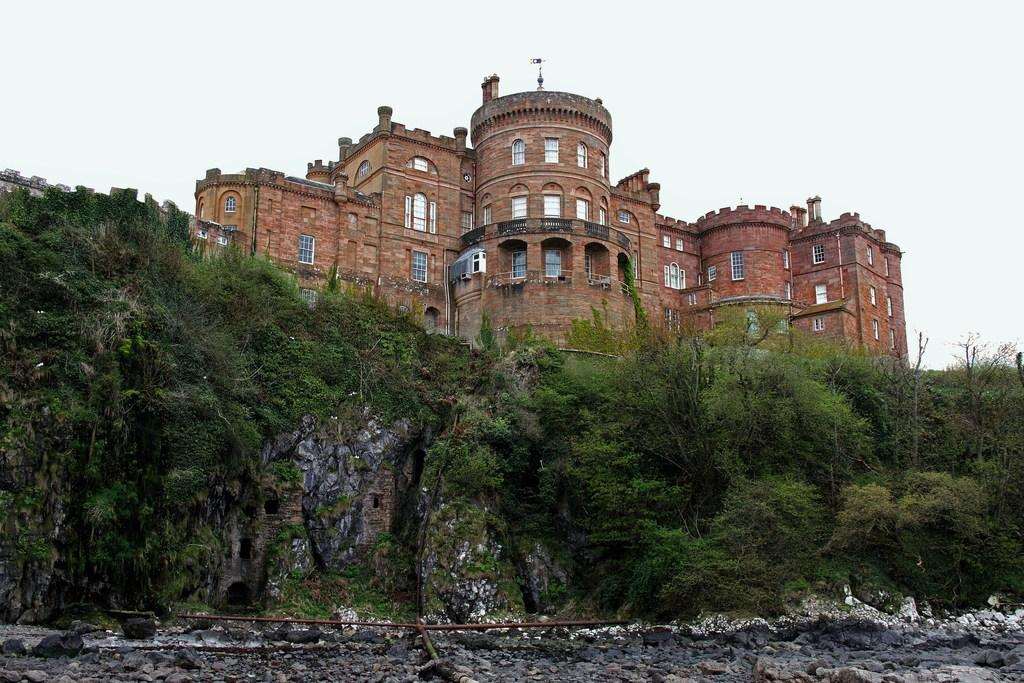What type of vegetation can be seen in the image? There are trees in the image. What type of structure is present in the image? There is a wall in the image. What material is present on the ground in the image? There are stones in the image. What can be seen in the background of the image? There is a building with windows in the background of the image. What is the building made of? The building has brick walls. What is visible in the sky in the image? The sky is visible in the background of the image. What type of prose can be seen on the library's shelves in the image? There is no library or shelves with prose present in the image. What type of ship can be seen sailing in the background of the image? There is no ship visible in the image; it features trees, a wall, stones, a building, and the sky. 